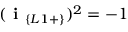Convert formula to latex. <formula><loc_0><loc_0><loc_500><loc_500>( i _ { \{ L 1 + \} } ) ^ { 2 } = - 1</formula> 